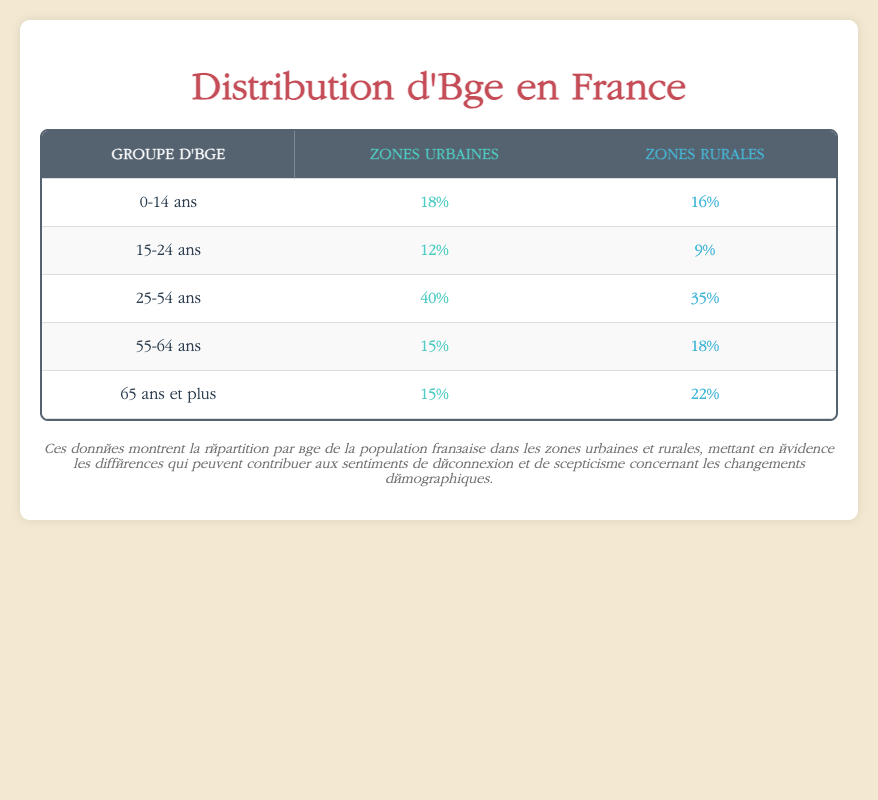What percentage of the urban population is aged 15-24? According to the table, the percentage of the urban population aged 15-24 is directly given as 12%.
Answer: 12% Which age group has the highest percentage in rural areas? From the table, the age group with the highest percentage in rural areas is 65 and older, which is 22%.
Answer: 65 and older What is the total percentage of the population in urban areas that is aged 0-14 and 15-24 combined? To find this, we add the percentages for the two age groups in urban areas: 18% (0-14) + 12% (15-24) = 30%.
Answer: 30% Is it true that more people aged 55-64 live in rural areas than in urban areas? Looking at the table, the percentage of people aged 55-64 in rural areas is 18%, while in urban areas, it is 15%. Since 18% > 15%, the statement is true.
Answer: Yes What is the difference in percentage between the urban and rural populations aged 25-54? The percentage of the urban population aged 25-54 is 40%, and in rural areas, it is 35%. The difference is calculated as 40% - 35% = 5%.
Answer: 5% What is the total percentage of the population aged 0-14 and those aged 65 and older in urban areas? We calculate this by adding the percentages for the two age groups in urban areas: 18% (0-14) + 15% (65 and older) = 33%.
Answer: 33% Is there a higher percentage of the younger population (0-24) in urban areas than in rural areas? In urban areas, the percentage for ages 0-14 is 18% and for 15-24 is 12%, summing up to 30%. In rural areas, the percentage for ages 0-14 is 16% and for 15-24 is 9%, summing up to 25%. Since 30% > 25%, the statement is true.
Answer: Yes How many more people aged 65 and older live in rural areas compared to urban areas? The percentage of people aged 65 and older in rural areas is 22%, while in urban areas it is 15%. The difference is 22% - 15% = 7%.
Answer: 7% What is the average population percentage for the age group 55-64 in both urban and rural areas? To find the average, we add the percentages for the age group in both areas: 15% (urban) + 18% (rural) = 33%. Then, we divide by the number of areas, which is 2. So, the average is 33% / 2 = 16.5%.
Answer: 16.5% 